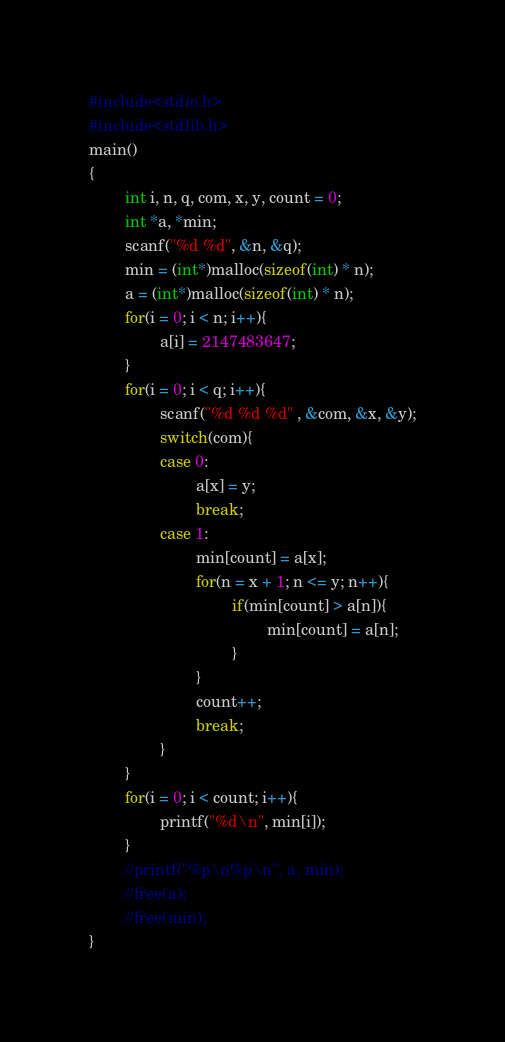<code> <loc_0><loc_0><loc_500><loc_500><_C_>#include<stdio.h>
#include<stdlib.h>
main()
{
        int i, n, q, com, x, y, count = 0;
        int *a, *min;
        scanf("%d %d", &n, &q);
        min = (int*)malloc(sizeof(int) * n);
        a = (int*)malloc(sizeof(int) * n);
        for(i = 0; i < n; i++){
                a[i] = 2147483647;
        }
        for(i = 0; i < q; i++){
                scanf("%d %d %d" , &com, &x, &y);
                switch(com){
                case 0:
                        a[x] = y;
                        break;
                case 1:
                        min[count] = a[x];
                        for(n = x + 1; n <= y; n++){
                                if(min[count] > a[n]){
                                        min[count] = a[n];
                                }
                        }
                        count++;
                        break;
                }
        }
        for(i = 0; i < count; i++){
                printf("%d\n", min[i]);
        }
        //printf("%p\n%p\n", a, min);
        //free(a);
        //free(min);
}</code> 